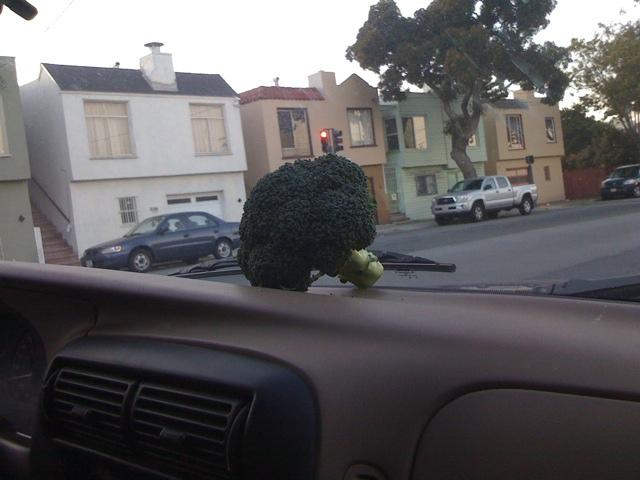Are there any cars driving on the road?
Be succinct. No. Is this a city street?
Write a very short answer. Yes. What is the food?
Give a very brief answer. Broccoli. Urban or suburban?
Answer briefly. Suburban. What is sticking out of the truck window?
Give a very brief answer. Broccoli. 